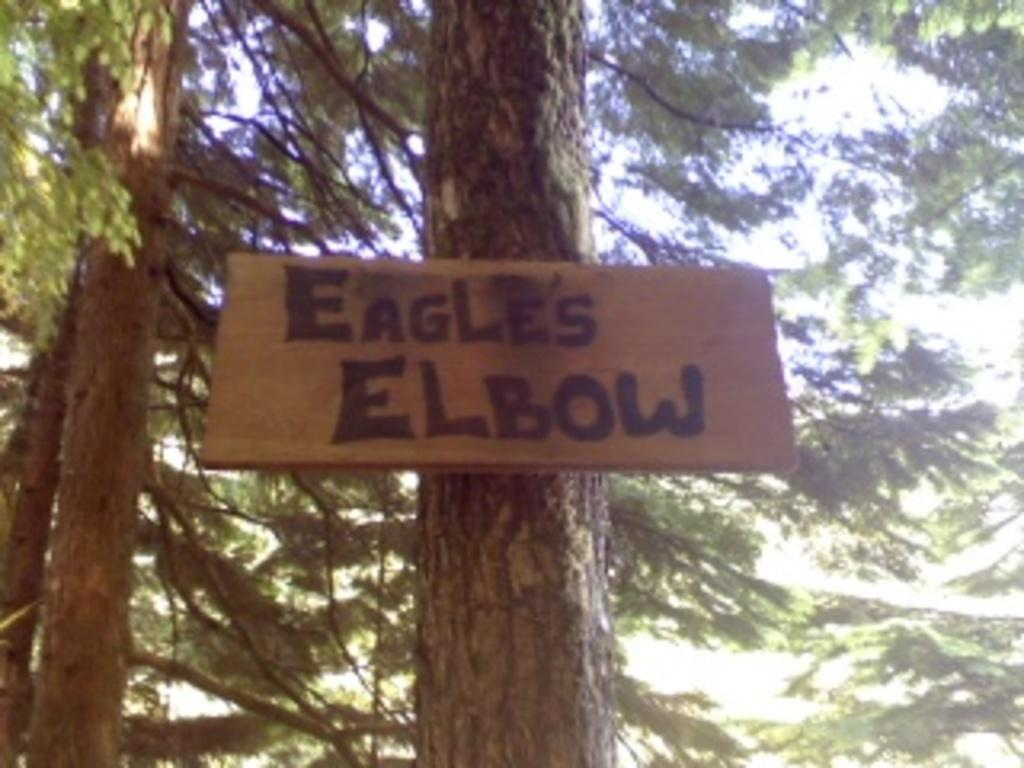What type of vegetation can be seen in the image? There are trees in the image. What object is present in the image besides the trees? There is a board in the image. What can be seen in the background of the image? The sky is visible in the background of the image. What type of pie is being served on the board in the image? There is no pie present in the image; it only features trees and a board. Who owns the property in the image? The image does not provide information about property ownership. 